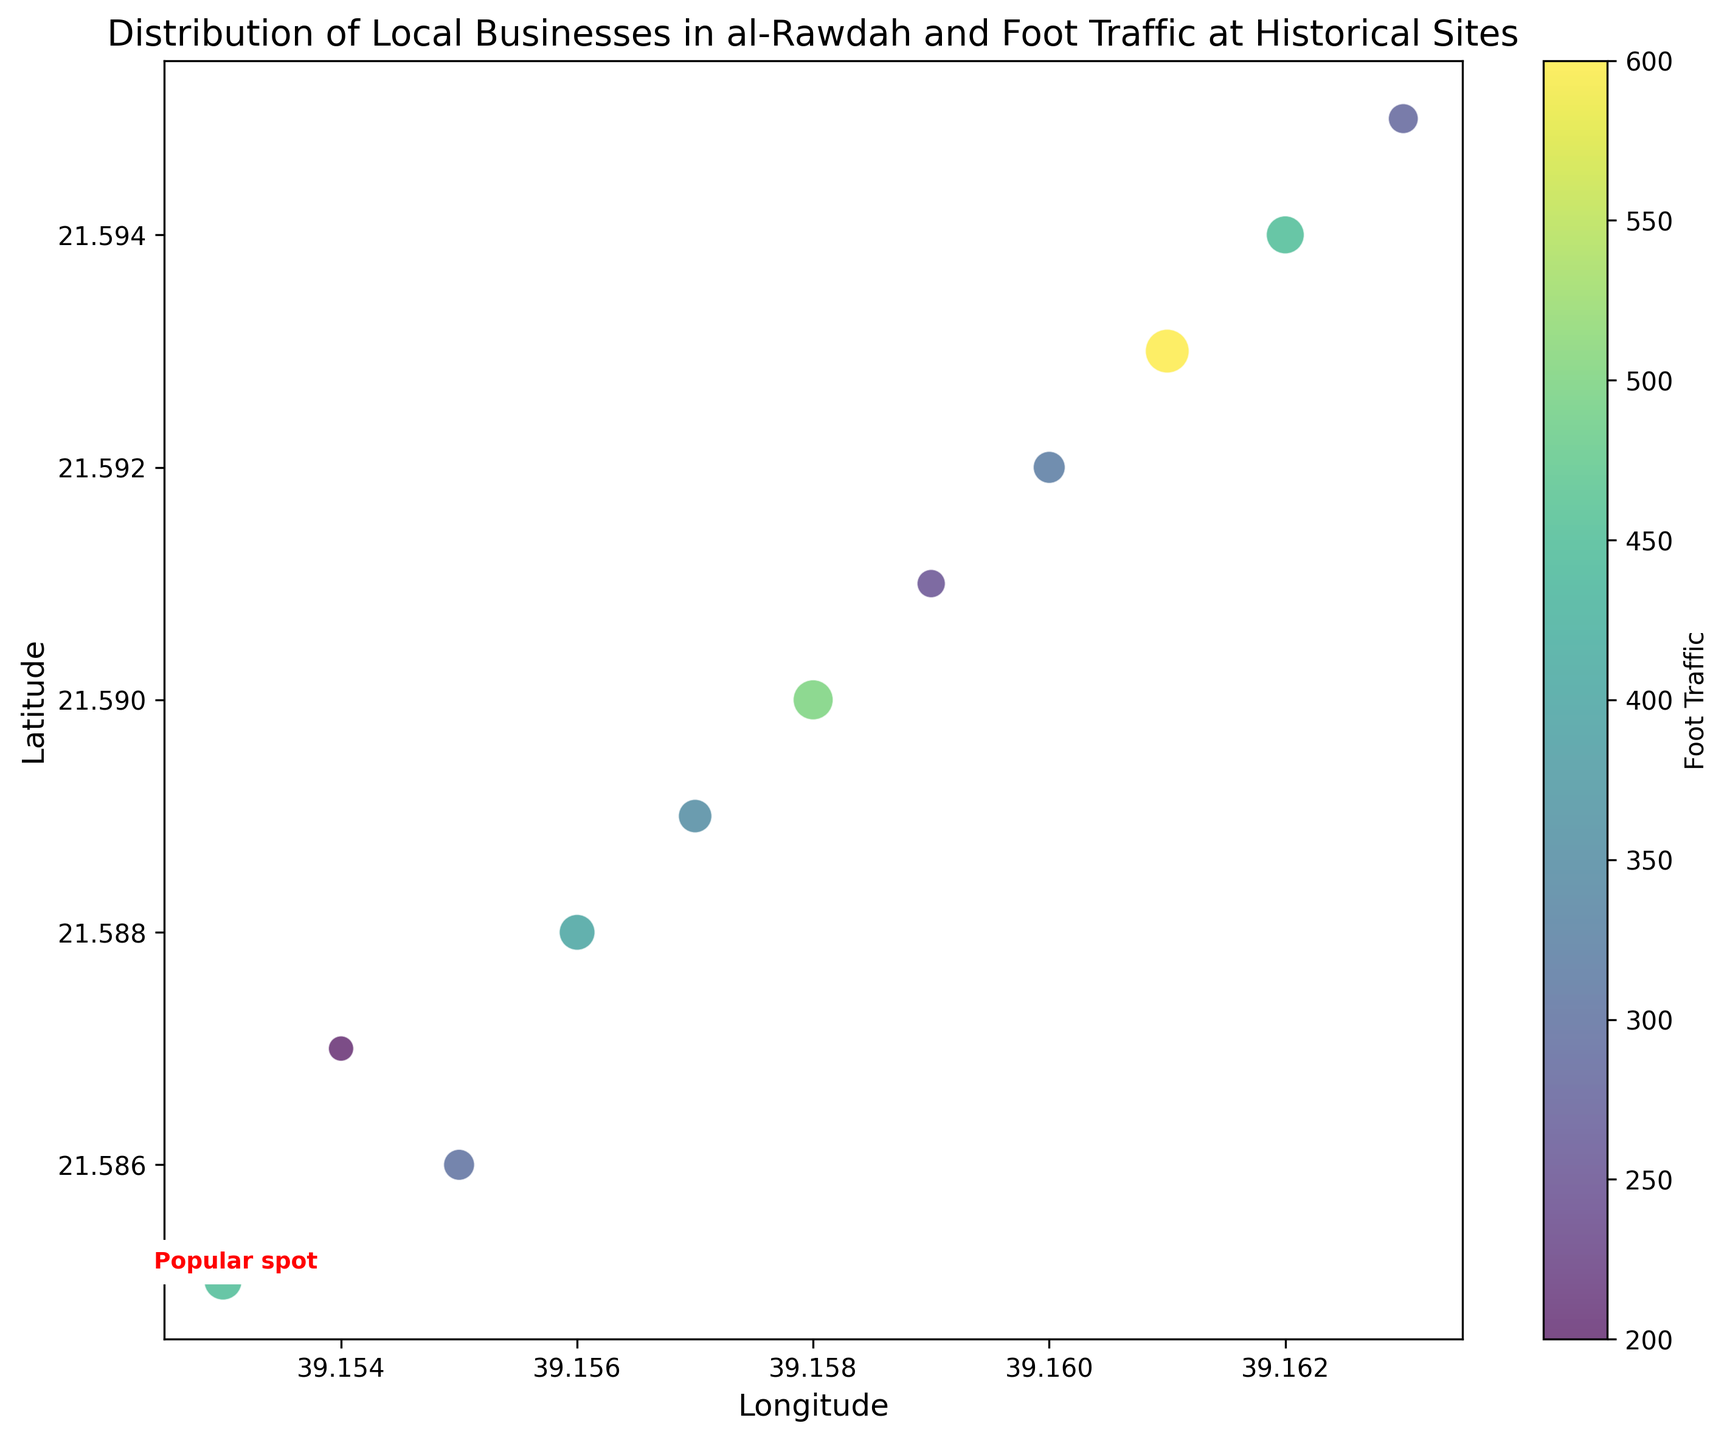What business has the highest foot traffic? By examining the color bar and the size of the circles on the scatter plot, the "Al-Rawdah Museum Gift Shop" has the highest foot traffic as indicated by the largest circle and the darkest color.
Answer: Al-Rawdah Museum Gift Shop Which business is annotated as a "Popular spot"? The scatter plot has a text annotation for "Al-Rawdah Café" labeling it as a "Popular spot."
Answer: Al-Rawdah Café What is the foot traffic difference between "Traditional Bakery" and "Vintage Tea House"? "Traditional Bakery" shows a foot traffic of 400, while "Vintage Tea House" shows 280. The difference is 400 - 280 = 120.
Answer: 120 Which businesses have a foot traffic of more than 400? The chart shows businesses with foot traffic indicated by the size and color of the circles. "Al-Rawdah Café," "Old Town Restaurant," "Al-Rawdah Museum Gift Shop," and "Cultural Art Gallery" have values greater than 400.
Answer: Al-Rawdah Café, Old Town Restaurant, Al-Rawdah Museum Gift Shop, Cultural Art Gallery Among "Heritage Bookstore" and "Local Handicrafts," which has higher foot traffic? "Heritage Bookstore" has a foot traffic of 300, and "Local Handicrafts" has 250. Thus, "Heritage Bookstore" has higher foot traffic.
Answer: Heritage Bookstore Estimate the average foot traffic for businesses located to the east of Al-Rawdah Café. Businesses to the east are "Heritage Bookstore (300)," "Antique Souvenir Shop (200)," "Traditional Bakery (400)," "Olive Crafts (350)," "Old Town Restaurant (500)," "Local Handicrafts (250)," "Historic Clothing Store (320)," "Al-Rawdah Museum Gift Shop (600)," "Cultural Art Gallery (450)," and "Vintage Tea House (280)." The sum is 3650/10 businesses = 365.
Answer: 365 What is the relationship between the location (latitude and longitude) and foot traffic in the scatter plot? Generally, businesses positioned more to the northeast (higher latitude and longitude) show higher foot traffic, indicated by larger and darker circles.
Answer: Higher latitude and longitude tend to have higher foot traffic Which business is closest in location to "Antique Souvenir Shop"? By examining the scatter plot, "Traditional Bakery" which is almost at the same latitude and slightly higher longitude, is closest to "Antique Souvenir Shop."
Answer: Traditional Bakery How many businesses have foot traffic exactly equal to 300? The plot indicates "Heritage Bookstore" with a foot traffic value of 300. Only this business meets the criterion.
Answer: 1 What is the foot traffic of "Old Town Restaurant," and how does it compare to "Olive Crafts"? "Old Town Restaurant" has a foot traffic of 500, and "Olive Crafts" has 350. The difference is 500 - 350 = 150.
Answer: Old Town Restaurant has 150 more foot traffic than Olive Crafts 